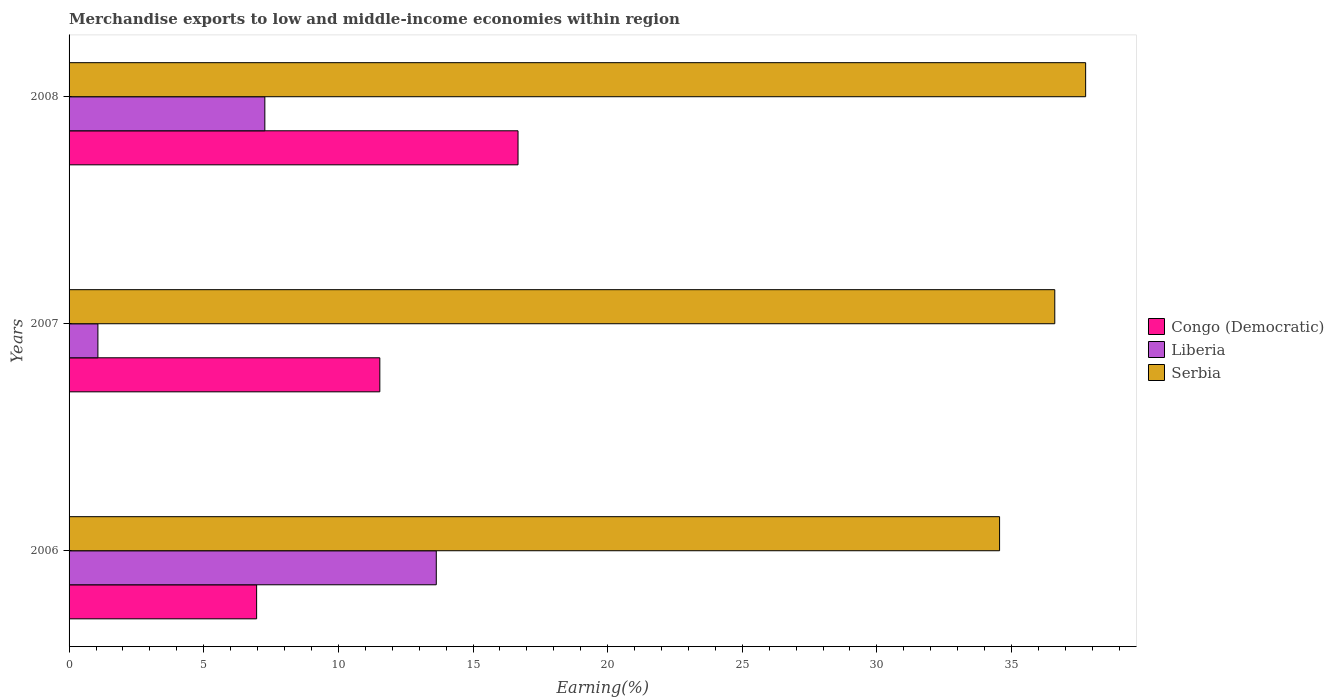How many different coloured bars are there?
Your answer should be very brief. 3. How many groups of bars are there?
Ensure brevity in your answer.  3. How many bars are there on the 3rd tick from the top?
Make the answer very short. 3. What is the label of the 2nd group of bars from the top?
Offer a terse response. 2007. In how many cases, is the number of bars for a given year not equal to the number of legend labels?
Your answer should be compact. 0. What is the percentage of amount earned from merchandise exports in Congo (Democratic) in 2006?
Give a very brief answer. 6.96. Across all years, what is the maximum percentage of amount earned from merchandise exports in Liberia?
Your answer should be very brief. 13.64. Across all years, what is the minimum percentage of amount earned from merchandise exports in Liberia?
Provide a succinct answer. 1.07. In which year was the percentage of amount earned from merchandise exports in Serbia maximum?
Provide a short and direct response. 2008. In which year was the percentage of amount earned from merchandise exports in Serbia minimum?
Your response must be concise. 2006. What is the total percentage of amount earned from merchandise exports in Serbia in the graph?
Your answer should be compact. 108.91. What is the difference between the percentage of amount earned from merchandise exports in Liberia in 2007 and that in 2008?
Keep it short and to the point. -6.2. What is the difference between the percentage of amount earned from merchandise exports in Serbia in 2006 and the percentage of amount earned from merchandise exports in Congo (Democratic) in 2008?
Provide a short and direct response. 17.88. What is the average percentage of amount earned from merchandise exports in Serbia per year?
Provide a succinct answer. 36.3. In the year 2008, what is the difference between the percentage of amount earned from merchandise exports in Congo (Democratic) and percentage of amount earned from merchandise exports in Liberia?
Offer a terse response. 9.4. In how many years, is the percentage of amount earned from merchandise exports in Serbia greater than 22 %?
Provide a short and direct response. 3. What is the ratio of the percentage of amount earned from merchandise exports in Serbia in 2006 to that in 2007?
Provide a short and direct response. 0.94. What is the difference between the highest and the second highest percentage of amount earned from merchandise exports in Congo (Democratic)?
Offer a very short reply. 5.13. What is the difference between the highest and the lowest percentage of amount earned from merchandise exports in Congo (Democratic)?
Make the answer very short. 9.71. What does the 1st bar from the top in 2008 represents?
Provide a short and direct response. Serbia. What does the 2nd bar from the bottom in 2006 represents?
Your answer should be very brief. Liberia. How many years are there in the graph?
Make the answer very short. 3. What is the difference between two consecutive major ticks on the X-axis?
Keep it short and to the point. 5. Are the values on the major ticks of X-axis written in scientific E-notation?
Offer a very short reply. No. Does the graph contain grids?
Ensure brevity in your answer.  No. How many legend labels are there?
Offer a terse response. 3. How are the legend labels stacked?
Your answer should be very brief. Vertical. What is the title of the graph?
Keep it short and to the point. Merchandise exports to low and middle-income economies within region. Does "Lower middle income" appear as one of the legend labels in the graph?
Provide a succinct answer. No. What is the label or title of the X-axis?
Keep it short and to the point. Earning(%). What is the label or title of the Y-axis?
Provide a short and direct response. Years. What is the Earning(%) in Congo (Democratic) in 2006?
Keep it short and to the point. 6.96. What is the Earning(%) in Liberia in 2006?
Provide a succinct answer. 13.64. What is the Earning(%) in Serbia in 2006?
Ensure brevity in your answer.  34.56. What is the Earning(%) of Congo (Democratic) in 2007?
Your answer should be very brief. 11.54. What is the Earning(%) of Liberia in 2007?
Offer a terse response. 1.07. What is the Earning(%) in Serbia in 2007?
Offer a very short reply. 36.61. What is the Earning(%) in Congo (Democratic) in 2008?
Provide a succinct answer. 16.67. What is the Earning(%) of Liberia in 2008?
Provide a succinct answer. 7.27. What is the Earning(%) of Serbia in 2008?
Ensure brevity in your answer.  37.75. Across all years, what is the maximum Earning(%) of Congo (Democratic)?
Make the answer very short. 16.67. Across all years, what is the maximum Earning(%) of Liberia?
Provide a succinct answer. 13.64. Across all years, what is the maximum Earning(%) in Serbia?
Ensure brevity in your answer.  37.75. Across all years, what is the minimum Earning(%) in Congo (Democratic)?
Give a very brief answer. 6.96. Across all years, what is the minimum Earning(%) in Liberia?
Your response must be concise. 1.07. Across all years, what is the minimum Earning(%) of Serbia?
Give a very brief answer. 34.56. What is the total Earning(%) of Congo (Democratic) in the graph?
Your answer should be compact. 35.18. What is the total Earning(%) in Liberia in the graph?
Make the answer very short. 21.98. What is the total Earning(%) in Serbia in the graph?
Your answer should be very brief. 108.91. What is the difference between the Earning(%) in Congo (Democratic) in 2006 and that in 2007?
Provide a succinct answer. -4.58. What is the difference between the Earning(%) in Liberia in 2006 and that in 2007?
Offer a very short reply. 12.57. What is the difference between the Earning(%) in Serbia in 2006 and that in 2007?
Ensure brevity in your answer.  -2.05. What is the difference between the Earning(%) in Congo (Democratic) in 2006 and that in 2008?
Offer a very short reply. -9.71. What is the difference between the Earning(%) of Liberia in 2006 and that in 2008?
Offer a terse response. 6.37. What is the difference between the Earning(%) of Serbia in 2006 and that in 2008?
Make the answer very short. -3.2. What is the difference between the Earning(%) of Congo (Democratic) in 2007 and that in 2008?
Make the answer very short. -5.13. What is the difference between the Earning(%) of Liberia in 2007 and that in 2008?
Give a very brief answer. -6.2. What is the difference between the Earning(%) of Serbia in 2007 and that in 2008?
Your response must be concise. -1.15. What is the difference between the Earning(%) in Congo (Democratic) in 2006 and the Earning(%) in Liberia in 2007?
Provide a succinct answer. 5.89. What is the difference between the Earning(%) in Congo (Democratic) in 2006 and the Earning(%) in Serbia in 2007?
Your answer should be compact. -29.64. What is the difference between the Earning(%) of Liberia in 2006 and the Earning(%) of Serbia in 2007?
Keep it short and to the point. -22.97. What is the difference between the Earning(%) in Congo (Democratic) in 2006 and the Earning(%) in Liberia in 2008?
Keep it short and to the point. -0.31. What is the difference between the Earning(%) in Congo (Democratic) in 2006 and the Earning(%) in Serbia in 2008?
Provide a succinct answer. -30.79. What is the difference between the Earning(%) in Liberia in 2006 and the Earning(%) in Serbia in 2008?
Provide a short and direct response. -24.11. What is the difference between the Earning(%) in Congo (Democratic) in 2007 and the Earning(%) in Liberia in 2008?
Keep it short and to the point. 4.27. What is the difference between the Earning(%) of Congo (Democratic) in 2007 and the Earning(%) of Serbia in 2008?
Offer a very short reply. -26.21. What is the difference between the Earning(%) in Liberia in 2007 and the Earning(%) in Serbia in 2008?
Make the answer very short. -36.68. What is the average Earning(%) in Congo (Democratic) per year?
Provide a short and direct response. 11.73. What is the average Earning(%) of Liberia per year?
Give a very brief answer. 7.33. What is the average Earning(%) of Serbia per year?
Your response must be concise. 36.3. In the year 2006, what is the difference between the Earning(%) in Congo (Democratic) and Earning(%) in Liberia?
Provide a succinct answer. -6.67. In the year 2006, what is the difference between the Earning(%) of Congo (Democratic) and Earning(%) of Serbia?
Provide a short and direct response. -27.59. In the year 2006, what is the difference between the Earning(%) in Liberia and Earning(%) in Serbia?
Provide a succinct answer. -20.92. In the year 2007, what is the difference between the Earning(%) of Congo (Democratic) and Earning(%) of Liberia?
Your answer should be very brief. 10.47. In the year 2007, what is the difference between the Earning(%) of Congo (Democratic) and Earning(%) of Serbia?
Offer a very short reply. -25.07. In the year 2007, what is the difference between the Earning(%) of Liberia and Earning(%) of Serbia?
Your answer should be compact. -35.53. In the year 2008, what is the difference between the Earning(%) in Congo (Democratic) and Earning(%) in Liberia?
Offer a very short reply. 9.4. In the year 2008, what is the difference between the Earning(%) in Congo (Democratic) and Earning(%) in Serbia?
Ensure brevity in your answer.  -21.08. In the year 2008, what is the difference between the Earning(%) of Liberia and Earning(%) of Serbia?
Offer a terse response. -30.48. What is the ratio of the Earning(%) of Congo (Democratic) in 2006 to that in 2007?
Offer a very short reply. 0.6. What is the ratio of the Earning(%) of Liberia in 2006 to that in 2007?
Your answer should be very brief. 12.73. What is the ratio of the Earning(%) of Serbia in 2006 to that in 2007?
Your answer should be compact. 0.94. What is the ratio of the Earning(%) in Congo (Democratic) in 2006 to that in 2008?
Offer a terse response. 0.42. What is the ratio of the Earning(%) in Liberia in 2006 to that in 2008?
Give a very brief answer. 1.88. What is the ratio of the Earning(%) of Serbia in 2006 to that in 2008?
Offer a very short reply. 0.92. What is the ratio of the Earning(%) of Congo (Democratic) in 2007 to that in 2008?
Your response must be concise. 0.69. What is the ratio of the Earning(%) of Liberia in 2007 to that in 2008?
Your answer should be very brief. 0.15. What is the ratio of the Earning(%) in Serbia in 2007 to that in 2008?
Offer a very short reply. 0.97. What is the difference between the highest and the second highest Earning(%) of Congo (Democratic)?
Your response must be concise. 5.13. What is the difference between the highest and the second highest Earning(%) in Liberia?
Your answer should be very brief. 6.37. What is the difference between the highest and the second highest Earning(%) in Serbia?
Provide a succinct answer. 1.15. What is the difference between the highest and the lowest Earning(%) in Congo (Democratic)?
Offer a terse response. 9.71. What is the difference between the highest and the lowest Earning(%) of Liberia?
Make the answer very short. 12.57. What is the difference between the highest and the lowest Earning(%) of Serbia?
Offer a very short reply. 3.2. 